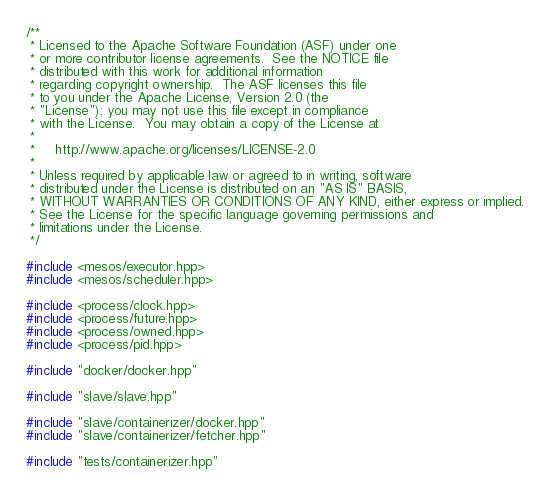<code> <loc_0><loc_0><loc_500><loc_500><_C++_>/**
 * Licensed to the Apache Software Foundation (ASF) under one
 * or more contributor license agreements.  See the NOTICE file
 * distributed with this work for additional information
 * regarding copyright ownership.  The ASF licenses this file
 * to you under the Apache License, Version 2.0 (the
 * "License"); you may not use this file except in compliance
 * with the License.  You may obtain a copy of the License at
 *
 *     http://www.apache.org/licenses/LICENSE-2.0
 *
 * Unless required by applicable law or agreed to in writing, software
 * distributed under the License is distributed on an "AS IS" BASIS,
 * WITHOUT WARRANTIES OR CONDITIONS OF ANY KIND, either express or implied.
 * See the License for the specific language governing permissions and
 * limitations under the License.
 */

#include <mesos/executor.hpp>
#include <mesos/scheduler.hpp>

#include <process/clock.hpp>
#include <process/future.hpp>
#include <process/owned.hpp>
#include <process/pid.hpp>

#include "docker/docker.hpp"

#include "slave/slave.hpp"

#include "slave/containerizer/docker.hpp"
#include "slave/containerizer/fetcher.hpp"

#include "tests/containerizer.hpp"</code> 